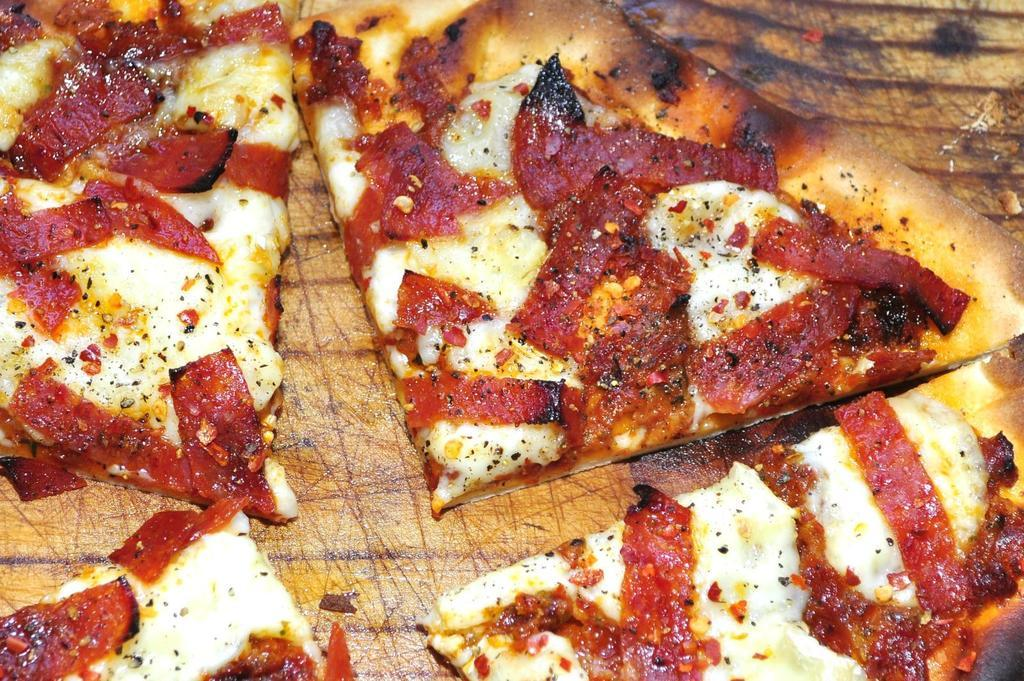What type of items can be seen in the image? The image contains food. What type of cheese can be seen floating on the waves in the image? There is no cheese or waves present in the image; it only contains food. 